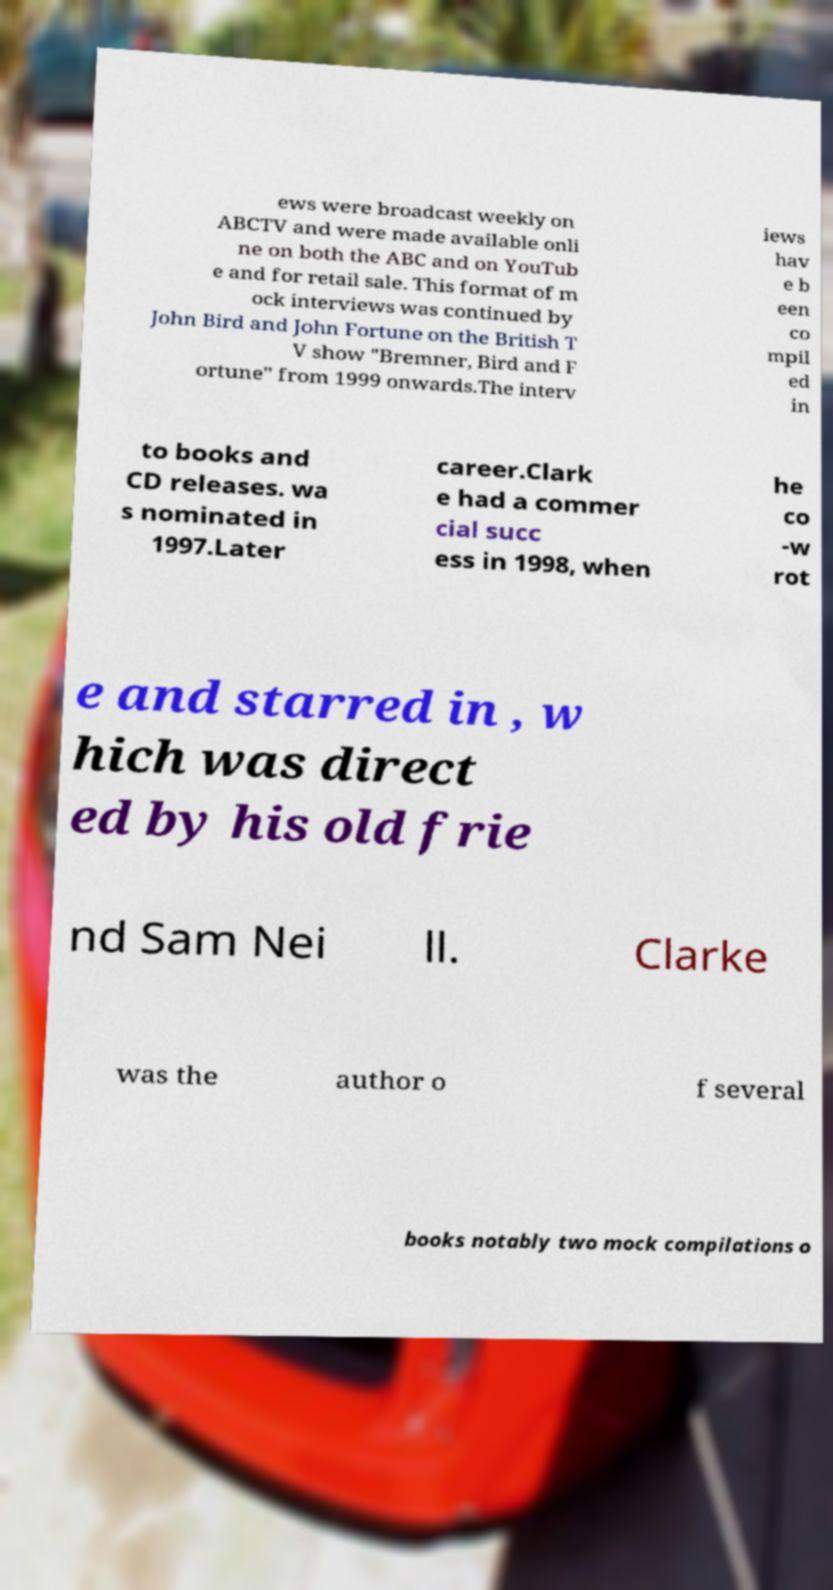Could you extract and type out the text from this image? ews were broadcast weekly on ABCTV and were made available onli ne on both the ABC and on YouTub e and for retail sale. This format of m ock interviews was continued by John Bird and John Fortune on the British T V show "Bremner, Bird and F ortune" from 1999 onwards.The interv iews hav e b een co mpil ed in to books and CD releases. wa s nominated in 1997.Later career.Clark e had a commer cial succ ess in 1998, when he co -w rot e and starred in , w hich was direct ed by his old frie nd Sam Nei ll. Clarke was the author o f several books notably two mock compilations o 